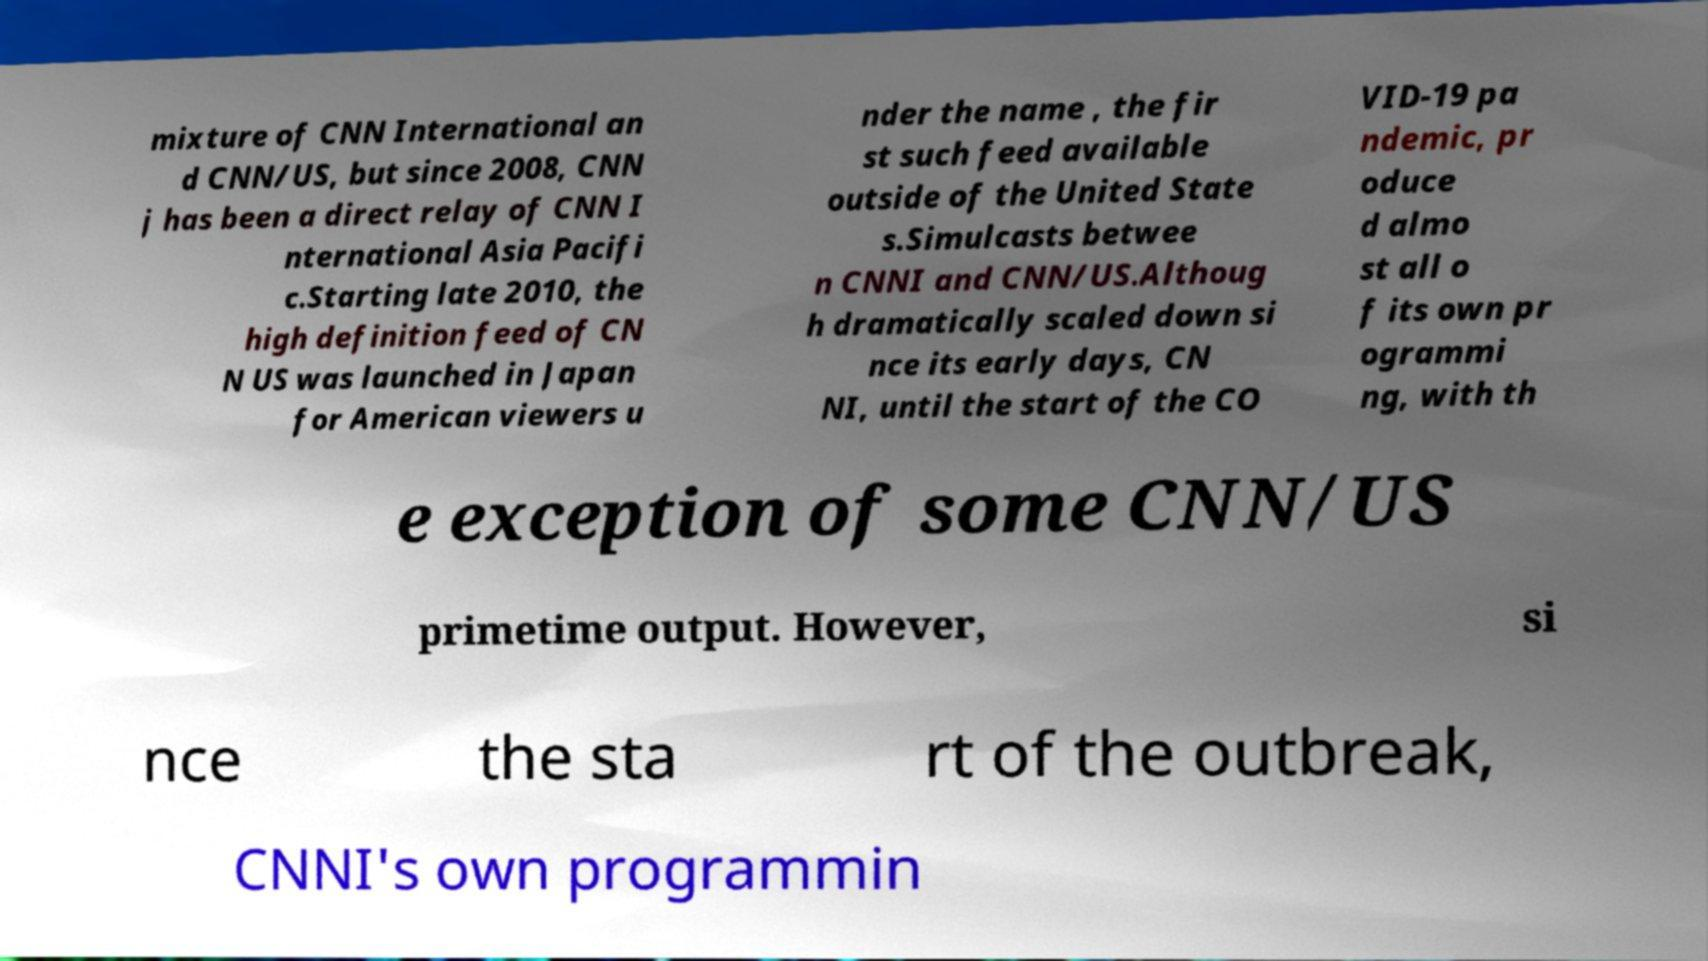There's text embedded in this image that I need extracted. Can you transcribe it verbatim? mixture of CNN International an d CNN/US, but since 2008, CNN j has been a direct relay of CNN I nternational Asia Pacifi c.Starting late 2010, the high definition feed of CN N US was launched in Japan for American viewers u nder the name , the fir st such feed available outside of the United State s.Simulcasts betwee n CNNI and CNN/US.Althoug h dramatically scaled down si nce its early days, CN NI, until the start of the CO VID-19 pa ndemic, pr oduce d almo st all o f its own pr ogrammi ng, with th e exception of some CNN/US primetime output. However, si nce the sta rt of the outbreak, CNNI's own programmin 